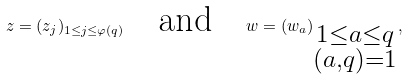<formula> <loc_0><loc_0><loc_500><loc_500>z = ( z _ { j } ) _ { 1 \leq j \leq \varphi ( q ) } \quad \text {and} \quad w = ( w _ { a } ) _ { \substack { 1 \leq a \leq q \\ ( a , q ) = 1 } } ,</formula> 